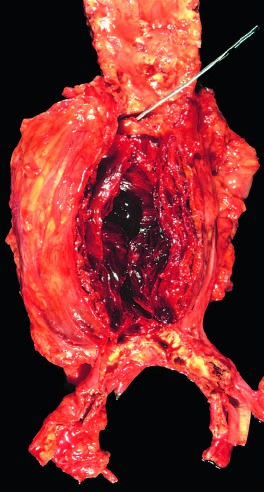s the lumen filled by a large, layered thrombus?
Answer the question using a single word or phrase. Yes 